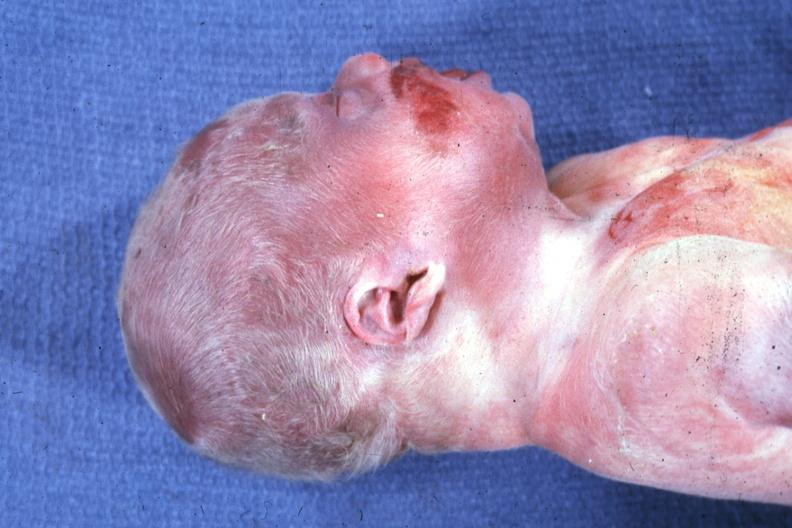what is present?
Answer the question using a single word or phrase. Beckwith-wiedemann syndrome 